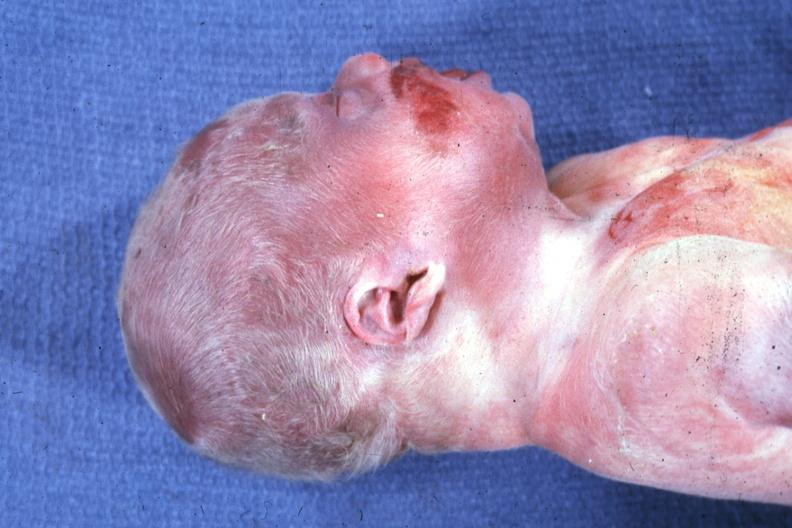what is present?
Answer the question using a single word or phrase. Beckwith-wiedemann syndrome 